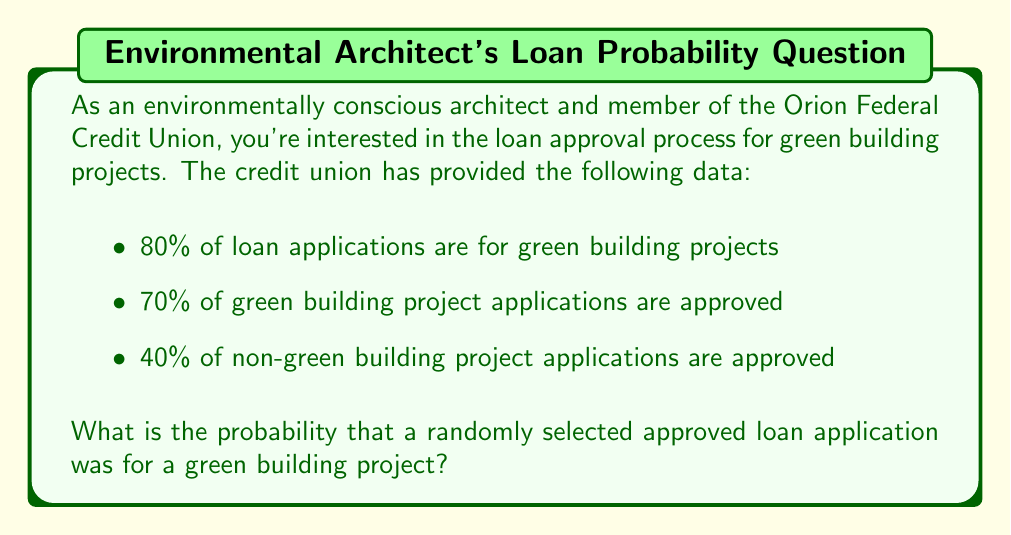What is the answer to this math problem? To solve this problem, we'll use Bayes' Theorem. Let's define our events:

G: The loan application is for a green building project
A: The loan application is approved

We want to find P(G|A), the probability that a loan is for a green building project given that it was approved.

Bayes' Theorem states:

$$ P(G|A) = \frac{P(A|G) \cdot P(G)}{P(A)} $$

We're given:
P(G) = 0.80 (80% of applications are for green projects)
P(A|G) = 0.70 (70% of green project applications are approved)
P(A|not G) = 0.40 (40% of non-green project applications are approved)

We need to calculate P(A) using the law of total probability:

$$ P(A) = P(A|G) \cdot P(G) + P(A|not G) \cdot P(not G) $$

$$ P(A) = 0.70 \cdot 0.80 + 0.40 \cdot 0.20 $$
$$ P(A) = 0.56 + 0.08 = 0.64 $$

Now we can apply Bayes' Theorem:

$$ P(G|A) = \frac{0.70 \cdot 0.80}{0.64} = \frac{0.56}{0.64} = 0.875 $$

Therefore, the probability that a randomly selected approved loan application was for a green building project is 0.875 or 87.5%.
Answer: 0.875 or 87.5% 